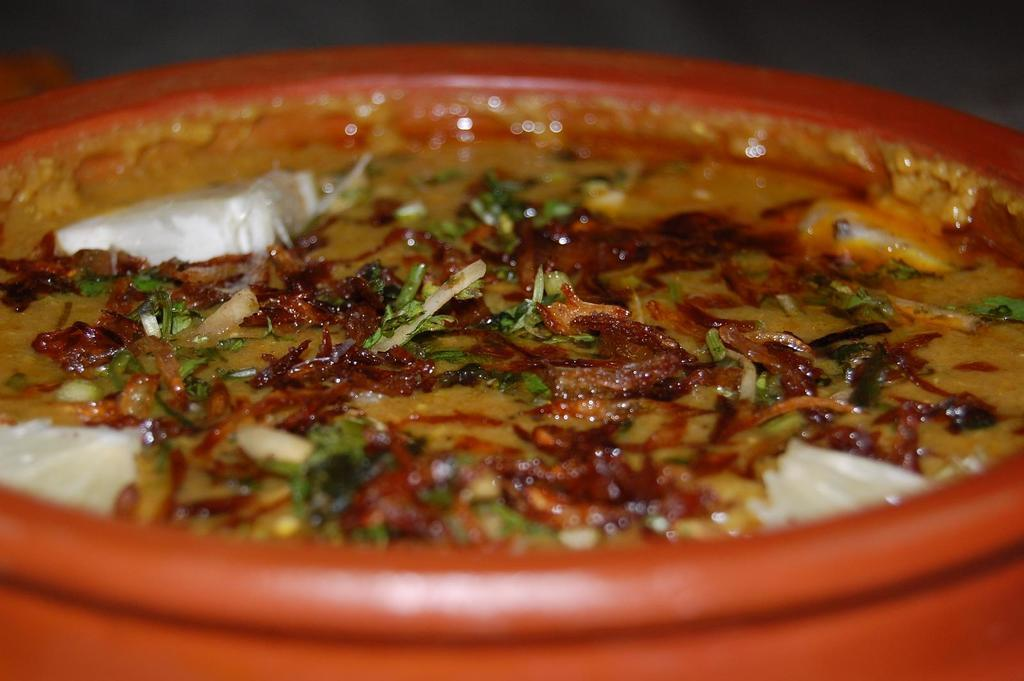What is in the bowl that is visible in the image? There is a food item in the bowl. Can you describe the background of the image? The background of the image is blurred. What type of prose is written on the caption of the image? There is no caption present in the image, and therefore no prose can be observed. 